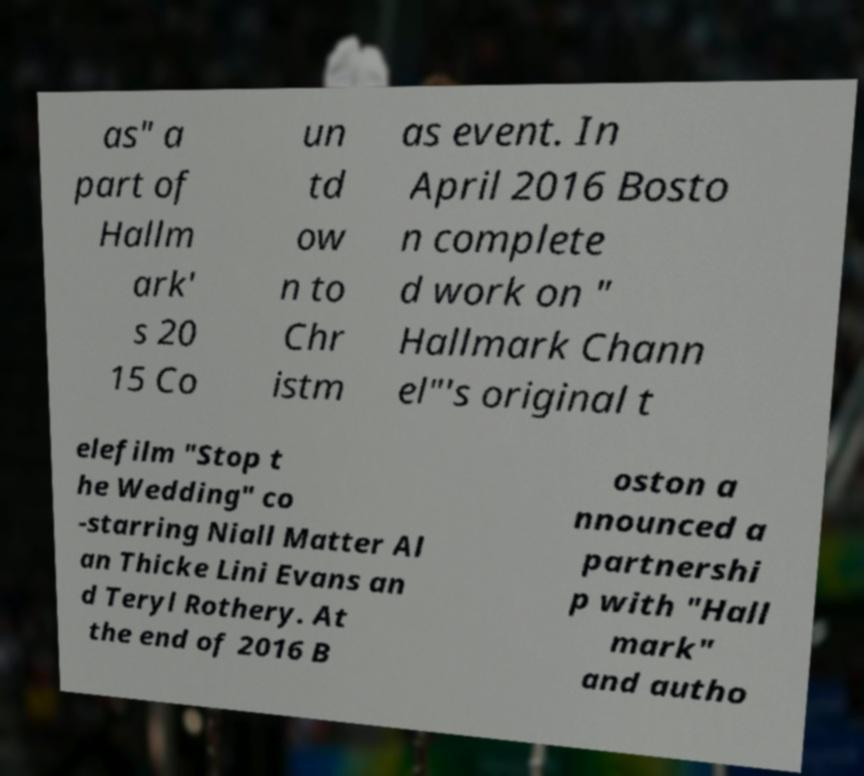Could you assist in decoding the text presented in this image and type it out clearly? as" a part of Hallm ark' s 20 15 Co un td ow n to Chr istm as event. In April 2016 Bosto n complete d work on " Hallmark Chann el"'s original t elefilm "Stop t he Wedding" co -starring Niall Matter Al an Thicke Lini Evans an d Teryl Rothery. At the end of 2016 B oston a nnounced a partnershi p with "Hall mark" and autho 